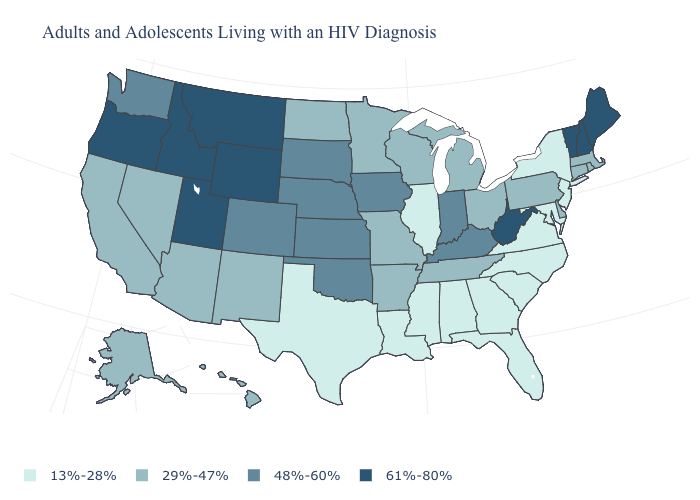What is the lowest value in states that border Vermont?
Quick response, please. 13%-28%. What is the value of Florida?
Write a very short answer. 13%-28%. What is the value of Oregon?
Concise answer only. 61%-80%. What is the value of Delaware?
Keep it brief. 29%-47%. How many symbols are there in the legend?
Keep it brief. 4. What is the highest value in states that border Colorado?
Write a very short answer. 61%-80%. What is the highest value in the USA?
Be succinct. 61%-80%. Which states have the lowest value in the USA?
Write a very short answer. Alabama, Florida, Georgia, Illinois, Louisiana, Maryland, Mississippi, New Jersey, New York, North Carolina, South Carolina, Texas, Virginia. Name the states that have a value in the range 61%-80%?
Give a very brief answer. Idaho, Maine, Montana, New Hampshire, Oregon, Utah, Vermont, West Virginia, Wyoming. Which states have the lowest value in the USA?
Answer briefly. Alabama, Florida, Georgia, Illinois, Louisiana, Maryland, Mississippi, New Jersey, New York, North Carolina, South Carolina, Texas, Virginia. Does Georgia have the highest value in the South?
Quick response, please. No. What is the value of New York?
Write a very short answer. 13%-28%. Name the states that have a value in the range 13%-28%?
Keep it brief. Alabama, Florida, Georgia, Illinois, Louisiana, Maryland, Mississippi, New Jersey, New York, North Carolina, South Carolina, Texas, Virginia. Name the states that have a value in the range 29%-47%?
Keep it brief. Alaska, Arizona, Arkansas, California, Connecticut, Delaware, Hawaii, Massachusetts, Michigan, Minnesota, Missouri, Nevada, New Mexico, North Dakota, Ohio, Pennsylvania, Rhode Island, Tennessee, Wisconsin. Is the legend a continuous bar?
Give a very brief answer. No. 